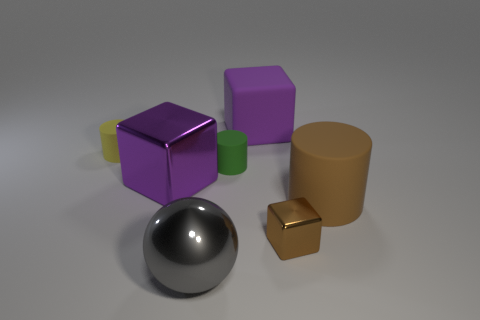The object that is both behind the big purple metallic object and left of the large metallic ball is made of what material?
Offer a terse response. Rubber. What number of cubes are the same color as the large cylinder?
Provide a short and direct response. 1. Is there any other thing of the same color as the small metal object?
Keep it short and to the point. Yes. There is a purple thing on the left side of the large metal thing that is on the right side of the big purple metallic cube; is there a big brown cylinder that is behind it?
Your response must be concise. No. Does the small object that is on the right side of the big matte block have the same shape as the big purple metallic thing?
Provide a succinct answer. Yes. Are there fewer tiny rubber things that are behind the tiny yellow matte cylinder than purple blocks that are to the right of the shiny ball?
Ensure brevity in your answer.  Yes. What is the material of the green thing?
Keep it short and to the point. Rubber. Does the matte cube have the same color as the shiny block that is behind the small metallic block?
Ensure brevity in your answer.  Yes. How many big purple metallic cubes are in front of the tiny brown metallic block?
Your response must be concise. 0. Are there fewer purple matte things that are on the left side of the big rubber cube than big brown shiny objects?
Give a very brief answer. No. 